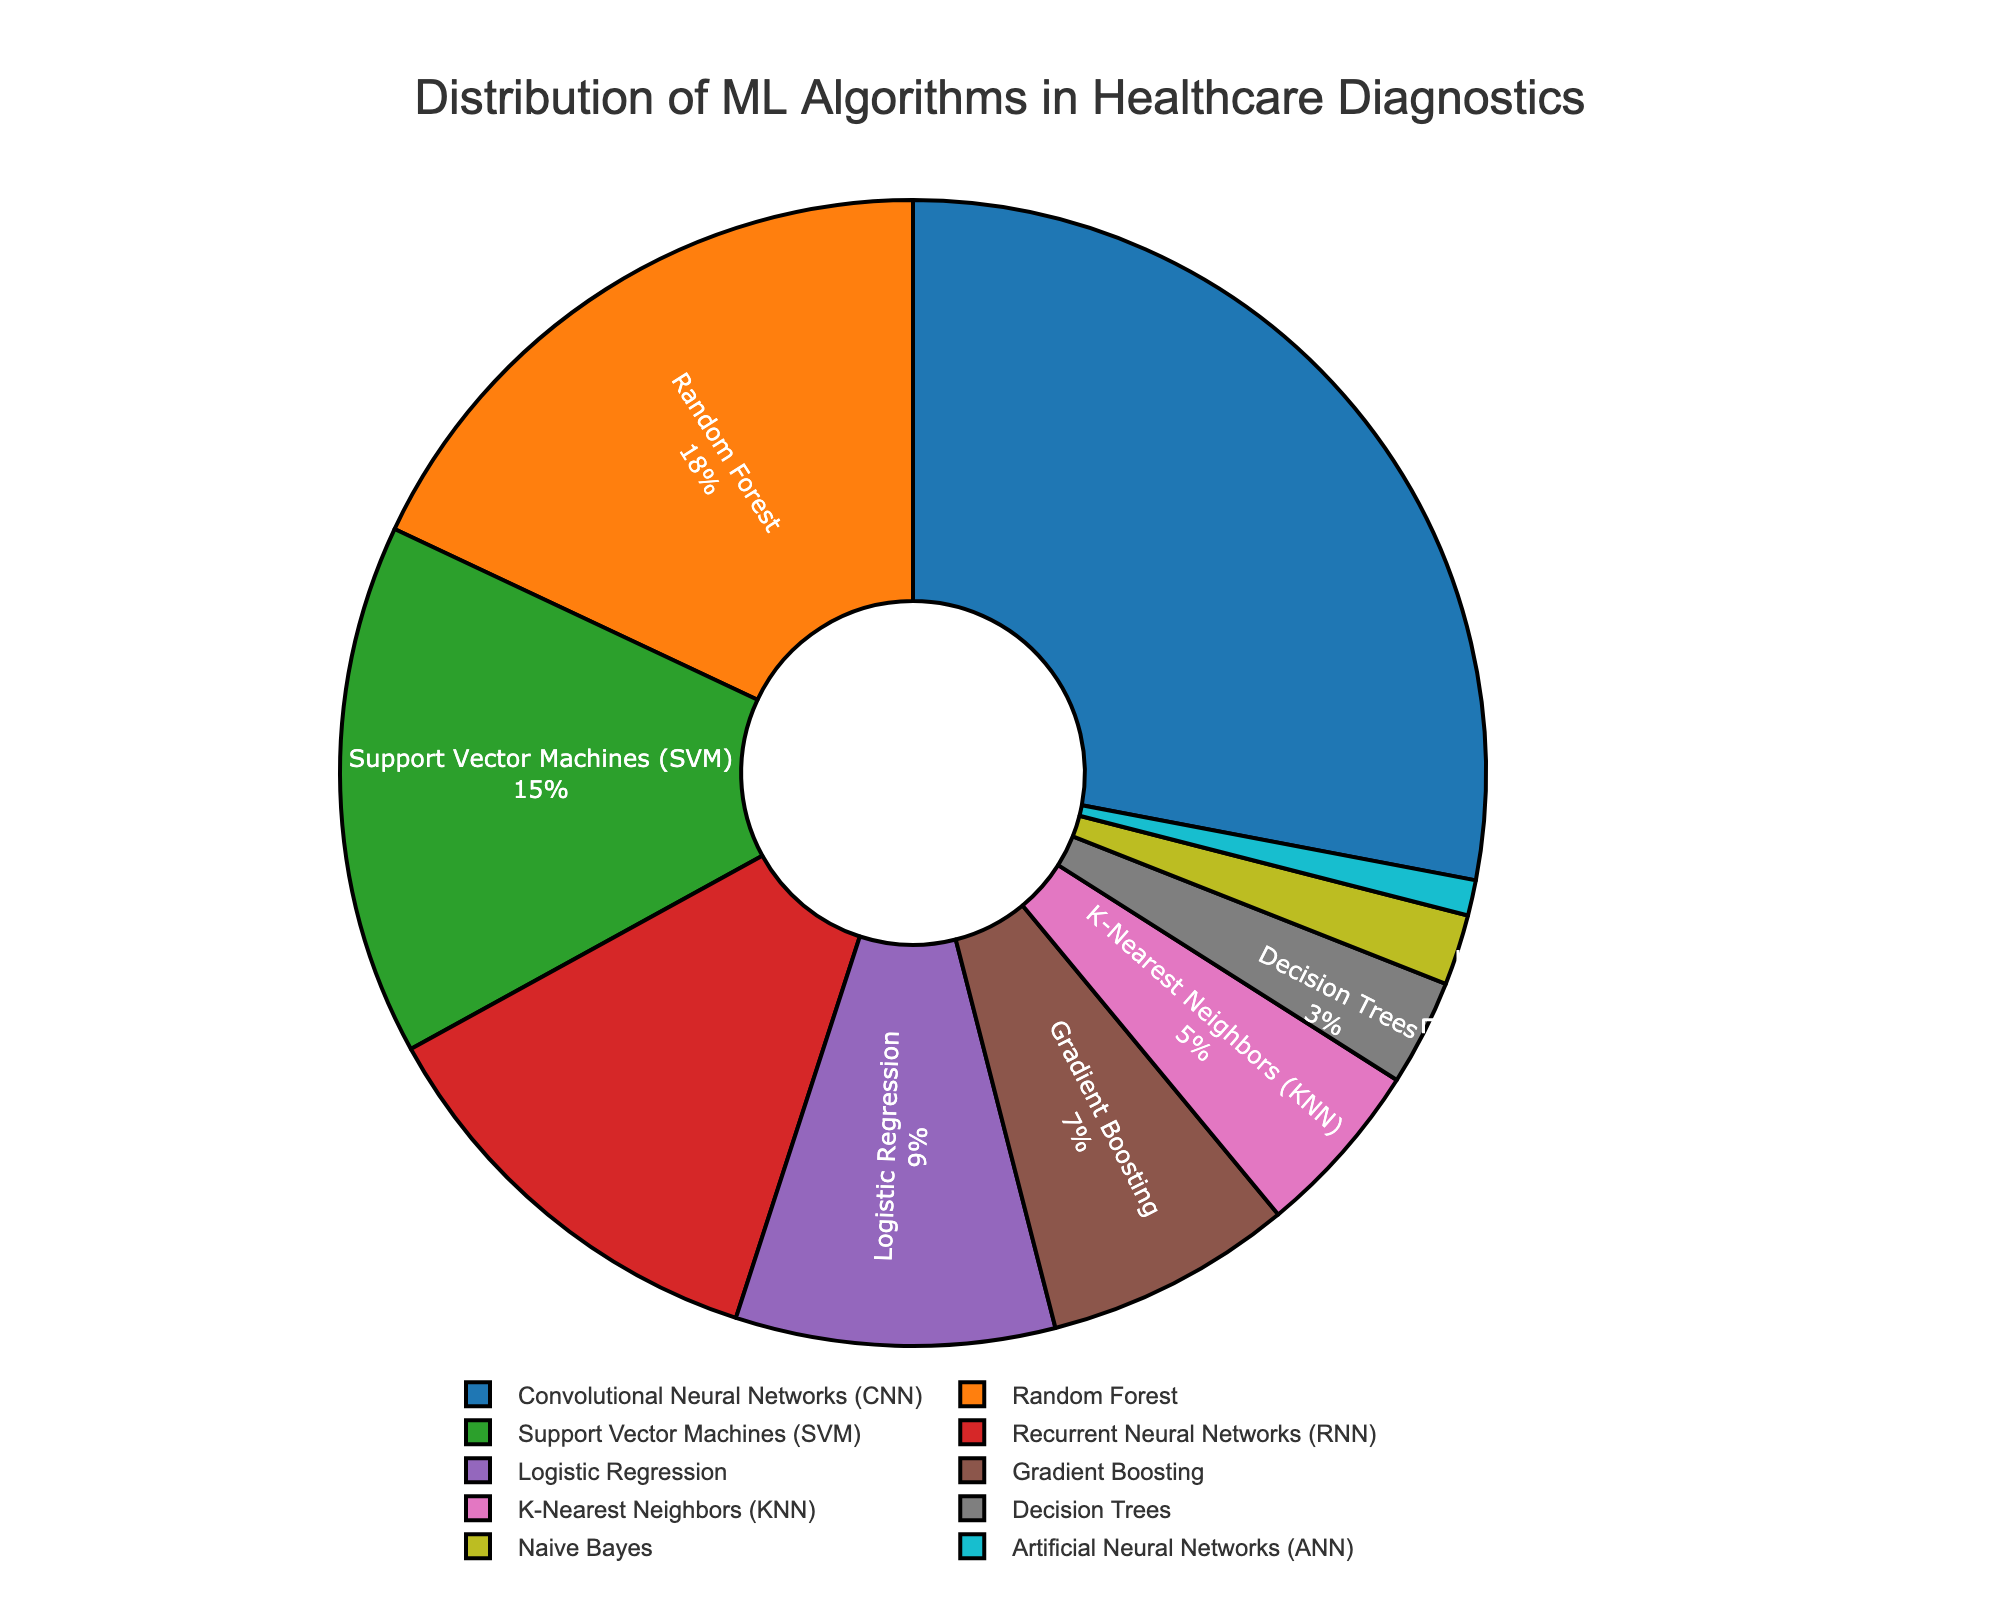Which algorithm is used the most in healthcare diagnostics? By observing the pie chart, we can see that Convolutional Neural Networks (CNN) have the largest segment.
Answer: Convolutional Neural Networks (CNN) Which two algorithms combined have a percentage closest to 30%? Adding the percentages of Decision Trees (3%) and Logistic Regression (9%) together gives 12%, and adding Naive Bayes (2%) and K-Nearest Neighbors (KNN) (5%) together gives 7%. The closest combination would be Recurrent Neural Networks (RNN) (12%) and Gradient Boosting (7%), which sum to 19%, not close but better than others. Therefore, combining support vector machines (SVM) (15%) and gradient boosting (7%) getting 22% which is closer to 30% is the best combination.
Answer: Support Vector Machines (SVM) and Gradient Boosting What is the difference in percentage between Random Forest and Artificial Neural Networks (ANN)? Random Forest has a percentage value of 18%, and ANN has 1%. The difference is 18% - 1% = 17%.
Answer: 17% Which algorithm has a slightly lower percentage than Support Vector Machines (SVM)? By examining the pie chart, we see that Recurrent Neural Networks (RNN) has a percentage of 12%, which is lower than the 15% of SVM.
Answer: Recurrent Neural Networks (RNN) If we sum the percentages of the three least used algorithms on the chart, what is the result? The three least used algorithms are Artificial Neural Networks (ANN) at 1%, Naive Bayes at 2%, and Decision Trees at 3%. Adding these gives 1% + 2% + 3% = 6%.
Answer: 6% Which color represents K-Nearest Neighbors (KNN) on the pie chart? By looking at the color legends of the pie chart, we can identify that the color corresponding to K-Nearest Neighbors (KNN) is pink.
Answer: Pink Is the proportion of Logistic Regression users greater than the combined users of Decision Trees and Naive Bayes? Logistic Regression has a percentage of 9%, while Decision Trees has 3% and Naive Bayes has 2%. The combined percentage for Decision Trees and Naive Bayes is 3% + 2% = 5%, which is less than 9%.
Answer: Yes How much more popular is Convolutional Neural Networks (CNN) compared to Gradient Boosting? Convolutional Neural Networks (CNN) has a percentage of 28%, and Gradient Boosting has 7%. The difference is 28% - 7% = 21%.
Answer: 21% Which algorithm represents a smaller portion than Logistic Regression yet has a higher portion than K-Nearest Neighbors (KNN)? Logistic Regression has 9%, and K-Nearest Neighbors (KNN) has 5%. The algorithm that falls between these two values in terms of percentage is Gradient Boosting, which has 7%.
Answer: Gradient Boosting If we consider both Recurrent Neural Networks (RNN) and Random Forest algorithms together, do they account for more than 40% of the distribution? RNN has 12%, and Random Forest has 18%. Adding these gives 12% + 18% = 30%, which is less than 40%.
Answer: No 